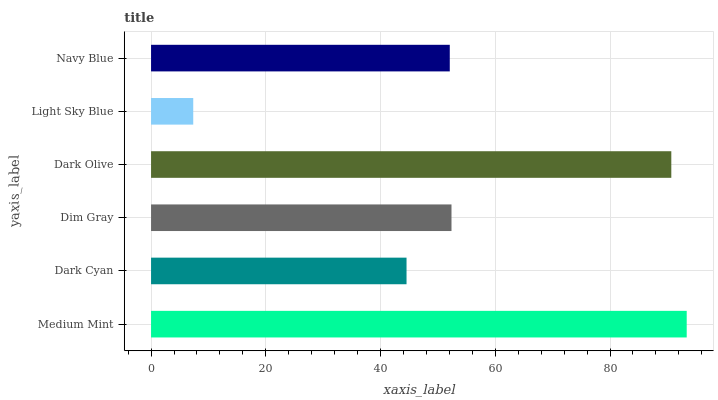Is Light Sky Blue the minimum?
Answer yes or no. Yes. Is Medium Mint the maximum?
Answer yes or no. Yes. Is Dark Cyan the minimum?
Answer yes or no. No. Is Dark Cyan the maximum?
Answer yes or no. No. Is Medium Mint greater than Dark Cyan?
Answer yes or no. Yes. Is Dark Cyan less than Medium Mint?
Answer yes or no. Yes. Is Dark Cyan greater than Medium Mint?
Answer yes or no. No. Is Medium Mint less than Dark Cyan?
Answer yes or no. No. Is Dim Gray the high median?
Answer yes or no. Yes. Is Navy Blue the low median?
Answer yes or no. Yes. Is Light Sky Blue the high median?
Answer yes or no. No. Is Medium Mint the low median?
Answer yes or no. No. 